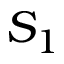<formula> <loc_0><loc_0><loc_500><loc_500>S _ { 1 }</formula> 